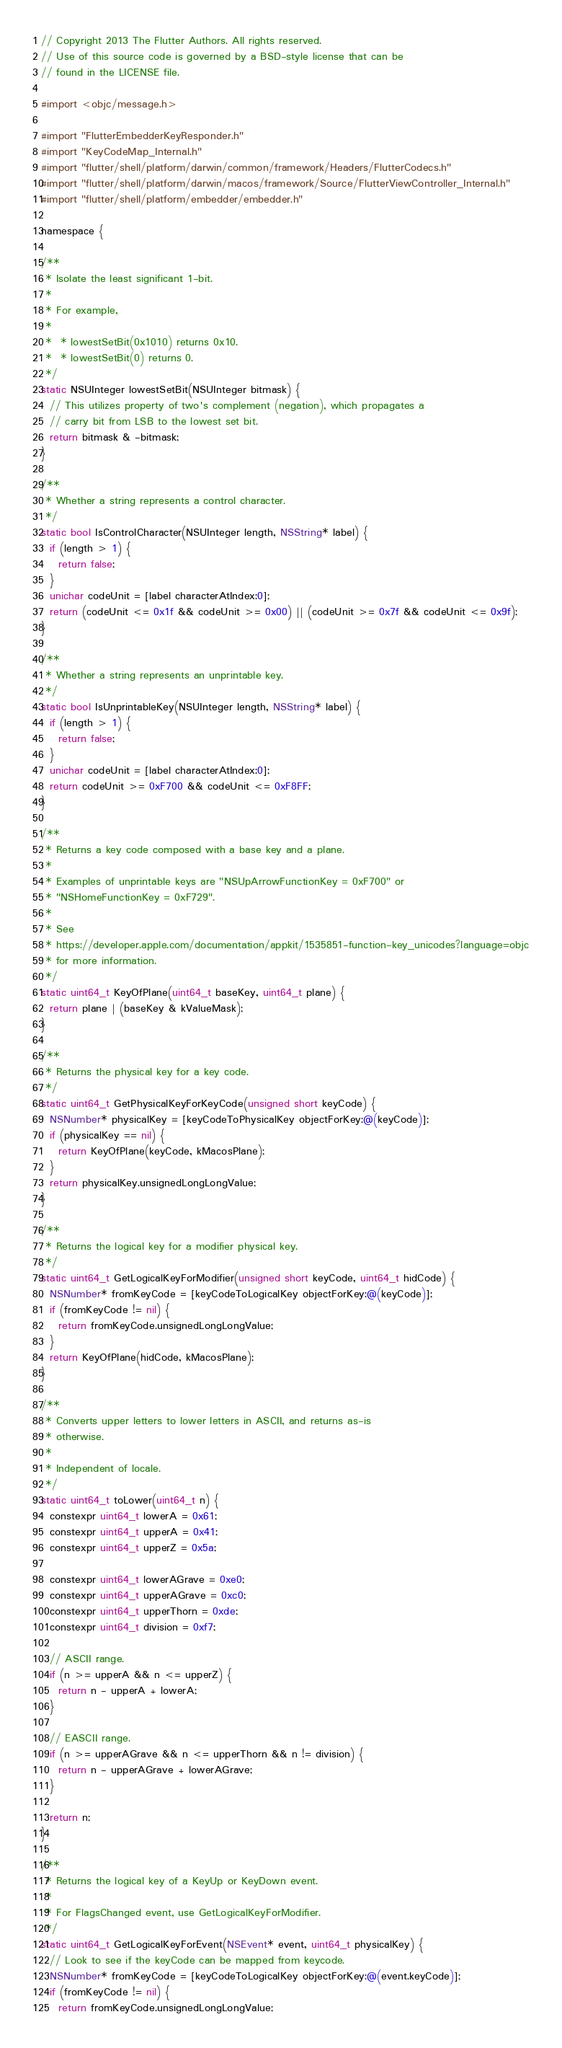<code> <loc_0><loc_0><loc_500><loc_500><_ObjectiveC_>// Copyright 2013 The Flutter Authors. All rights reserved.
// Use of this source code is governed by a BSD-style license that can be
// found in the LICENSE file.

#import <objc/message.h>

#import "FlutterEmbedderKeyResponder.h"
#import "KeyCodeMap_Internal.h"
#import "flutter/shell/platform/darwin/common/framework/Headers/FlutterCodecs.h"
#import "flutter/shell/platform/darwin/macos/framework/Source/FlutterViewController_Internal.h"
#import "flutter/shell/platform/embedder/embedder.h"

namespace {

/**
 * Isolate the least significant 1-bit.
 *
 * For example,
 *
 *  * lowestSetBit(0x1010) returns 0x10.
 *  * lowestSetBit(0) returns 0.
 */
static NSUInteger lowestSetBit(NSUInteger bitmask) {
  // This utilizes property of two's complement (negation), which propagates a
  // carry bit from LSB to the lowest set bit.
  return bitmask & -bitmask;
}

/**
 * Whether a string represents a control character.
 */
static bool IsControlCharacter(NSUInteger length, NSString* label) {
  if (length > 1) {
    return false;
  }
  unichar codeUnit = [label characterAtIndex:0];
  return (codeUnit <= 0x1f && codeUnit >= 0x00) || (codeUnit >= 0x7f && codeUnit <= 0x9f);
}

/**
 * Whether a string represents an unprintable key.
 */
static bool IsUnprintableKey(NSUInteger length, NSString* label) {
  if (length > 1) {
    return false;
  }
  unichar codeUnit = [label characterAtIndex:0];
  return codeUnit >= 0xF700 && codeUnit <= 0xF8FF;
}

/**
 * Returns a key code composed with a base key and a plane.
 *
 * Examples of unprintable keys are "NSUpArrowFunctionKey = 0xF700" or
 * "NSHomeFunctionKey = 0xF729".
 *
 * See
 * https://developer.apple.com/documentation/appkit/1535851-function-key_unicodes?language=objc
 * for more information.
 */
static uint64_t KeyOfPlane(uint64_t baseKey, uint64_t plane) {
  return plane | (baseKey & kValueMask);
}

/**
 * Returns the physical key for a key code.
 */
static uint64_t GetPhysicalKeyForKeyCode(unsigned short keyCode) {
  NSNumber* physicalKey = [keyCodeToPhysicalKey objectForKey:@(keyCode)];
  if (physicalKey == nil) {
    return KeyOfPlane(keyCode, kMacosPlane);
  }
  return physicalKey.unsignedLongLongValue;
}

/**
 * Returns the logical key for a modifier physical key.
 */
static uint64_t GetLogicalKeyForModifier(unsigned short keyCode, uint64_t hidCode) {
  NSNumber* fromKeyCode = [keyCodeToLogicalKey objectForKey:@(keyCode)];
  if (fromKeyCode != nil) {
    return fromKeyCode.unsignedLongLongValue;
  }
  return KeyOfPlane(hidCode, kMacosPlane);
}

/**
 * Converts upper letters to lower letters in ASCII, and returns as-is
 * otherwise.
 *
 * Independent of locale.
 */
static uint64_t toLower(uint64_t n) {
  constexpr uint64_t lowerA = 0x61;
  constexpr uint64_t upperA = 0x41;
  constexpr uint64_t upperZ = 0x5a;

  constexpr uint64_t lowerAGrave = 0xe0;
  constexpr uint64_t upperAGrave = 0xc0;
  constexpr uint64_t upperThorn = 0xde;
  constexpr uint64_t division = 0xf7;

  // ASCII range.
  if (n >= upperA && n <= upperZ) {
    return n - upperA + lowerA;
  }

  // EASCII range.
  if (n >= upperAGrave && n <= upperThorn && n != division) {
    return n - upperAGrave + lowerAGrave;
  }

  return n;
}

/**
 * Returns the logical key of a KeyUp or KeyDown event.
 *
 * For FlagsChanged event, use GetLogicalKeyForModifier.
 */
static uint64_t GetLogicalKeyForEvent(NSEvent* event, uint64_t physicalKey) {
  // Look to see if the keyCode can be mapped from keycode.
  NSNumber* fromKeyCode = [keyCodeToLogicalKey objectForKey:@(event.keyCode)];
  if (fromKeyCode != nil) {
    return fromKeyCode.unsignedLongLongValue;</code> 